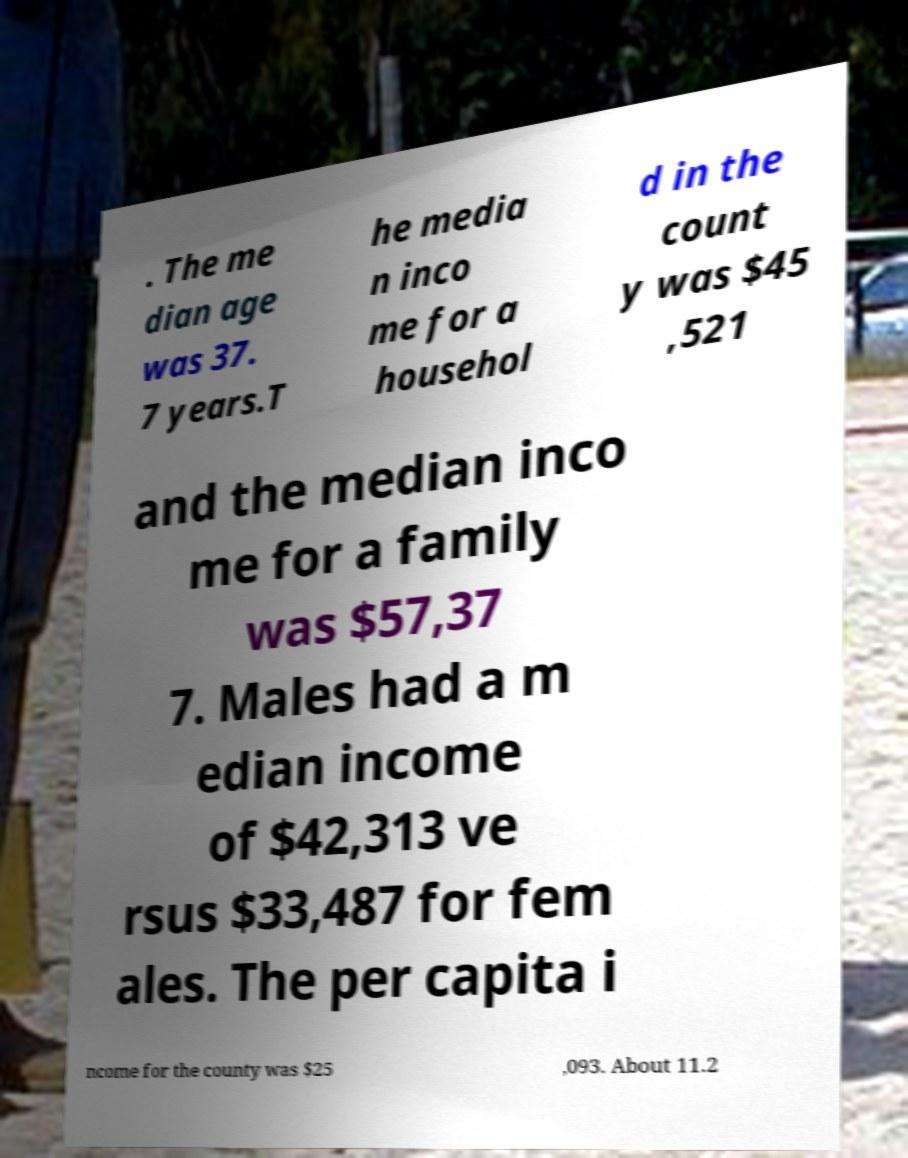Please read and relay the text visible in this image. What does it say? . The me dian age was 37. 7 years.T he media n inco me for a househol d in the count y was $45 ,521 and the median inco me for a family was $57,37 7. Males had a m edian income of $42,313 ve rsus $33,487 for fem ales. The per capita i ncome for the county was $25 ,093. About 11.2 